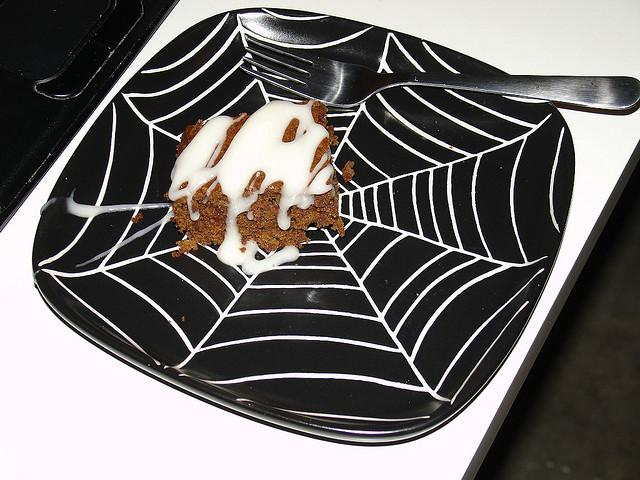What design is painted onto the plate? spider web 